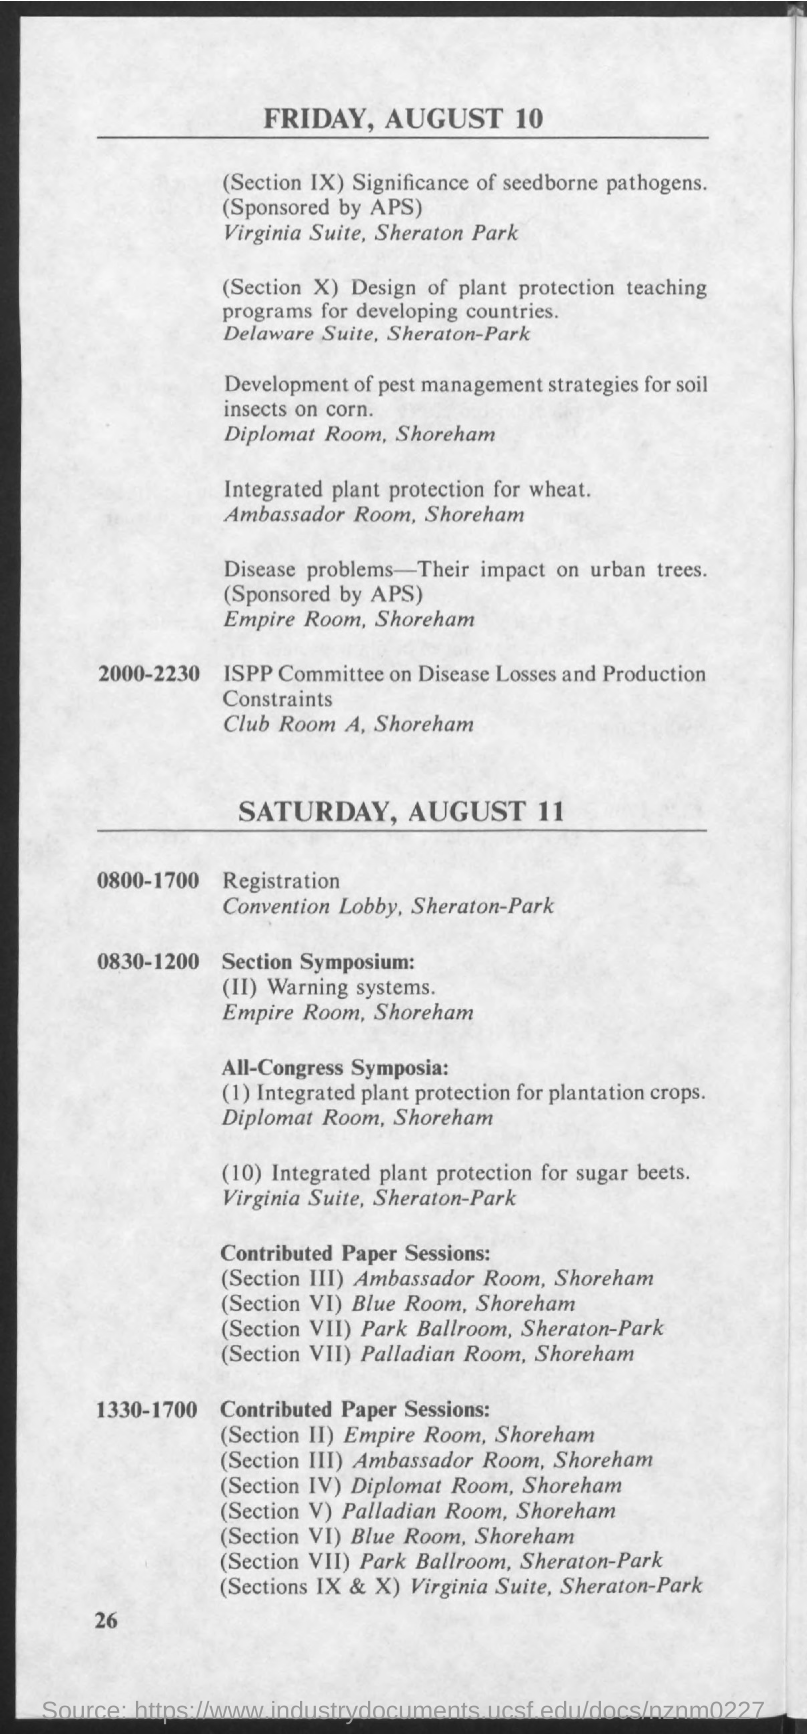What is the Page Number?
Keep it short and to the point. 26. What is the first date mentioned in the document?
Provide a short and direct response. Friday, August 10. What is the second date mentioned in the document?
Offer a terse response. Saturday, August 11. 